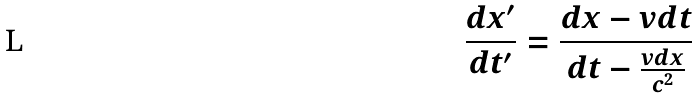Convert formula to latex. <formula><loc_0><loc_0><loc_500><loc_500>\frac { d x ^ { \prime } } { d t ^ { \prime } } = \frac { d x - v d t } { d t - \frac { v d x } { c ^ { 2 } } }</formula> 